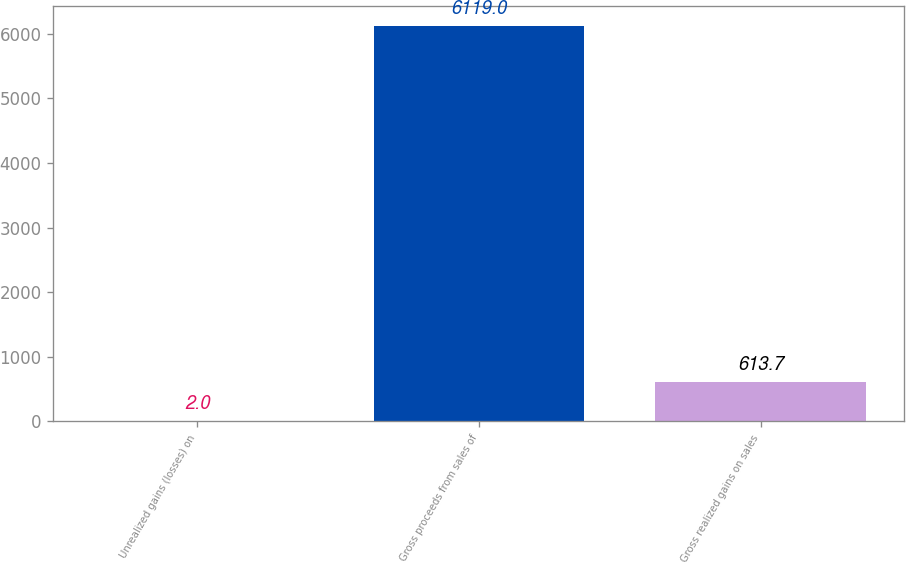<chart> <loc_0><loc_0><loc_500><loc_500><bar_chart><fcel>Unrealized gains (losses) on<fcel>Gross proceeds from sales of<fcel>Gross realized gains on sales<nl><fcel>2<fcel>6119<fcel>613.7<nl></chart> 